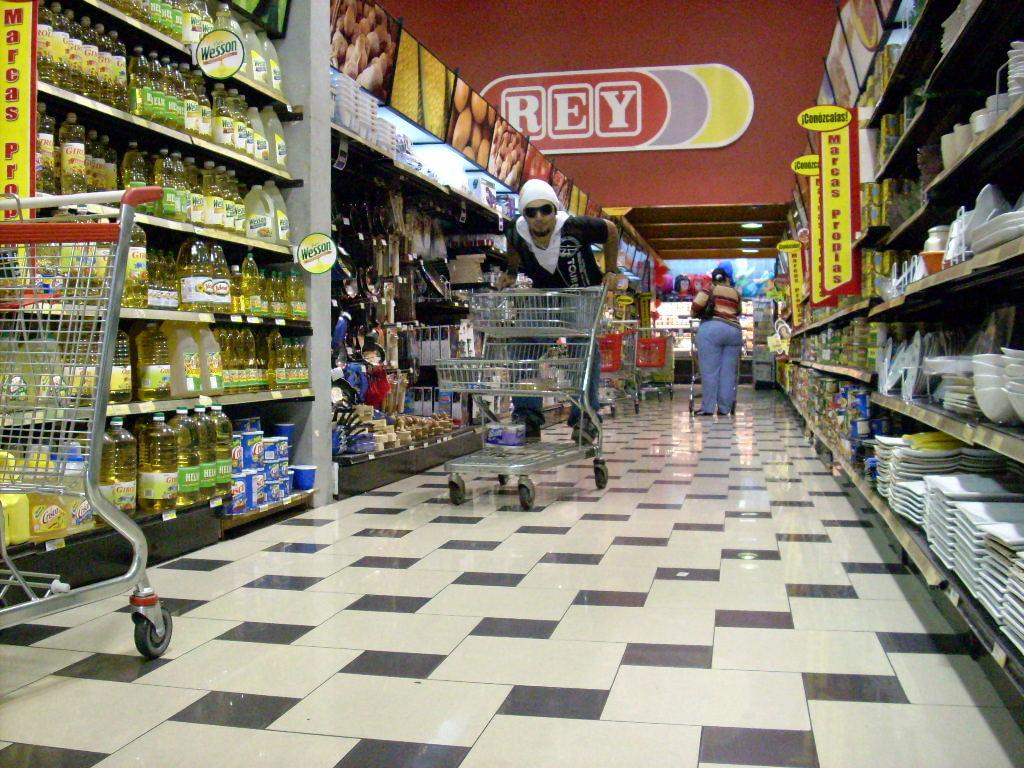What is the person in the image doing? The person is standing in a tray in the image. Can you describe the other person visible in the image? There is another person visible in the background of the image. What can be seen on the right side of the image? There are plates on the right side of the image. What is located on the left side of the image? There are food items on the left side of the image. What type of powder is being used by the person in the image? There is: There is no powder visible or mentioned in the image; the person is standing in a tray, and there are plates and food items present. 